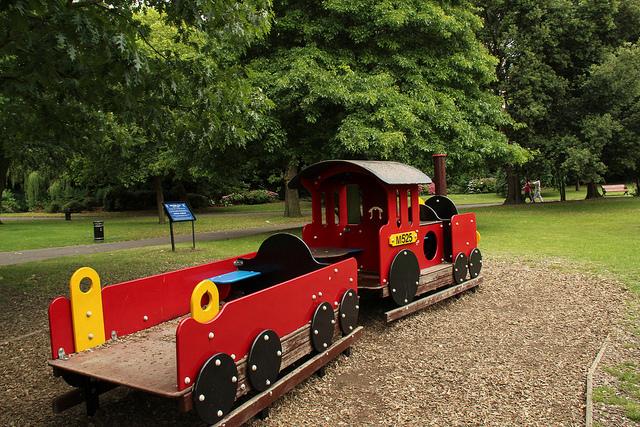What time did the children's park close?
Write a very short answer. 6:00. What color are the trees in this picture?
Short answer required. Green. Is this train real?
Be succinct. No. 